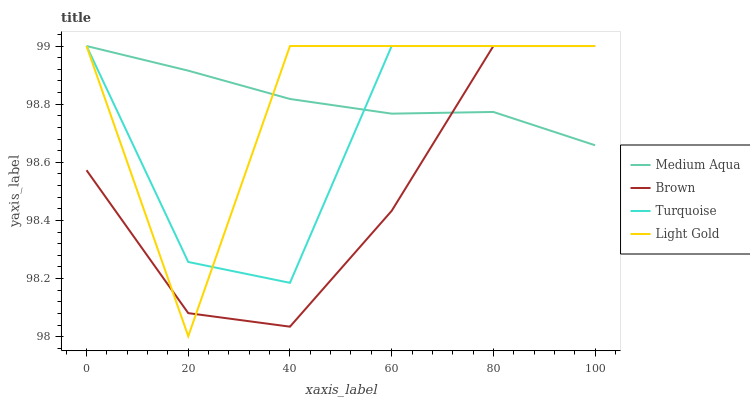Does Brown have the minimum area under the curve?
Answer yes or no. Yes. Does Medium Aqua have the maximum area under the curve?
Answer yes or no. Yes. Does Turquoise have the minimum area under the curve?
Answer yes or no. No. Does Turquoise have the maximum area under the curve?
Answer yes or no. No. Is Medium Aqua the smoothest?
Answer yes or no. Yes. Is Light Gold the roughest?
Answer yes or no. Yes. Is Turquoise the smoothest?
Answer yes or no. No. Is Turquoise the roughest?
Answer yes or no. No. Does Light Gold have the lowest value?
Answer yes or no. Yes. Does Turquoise have the lowest value?
Answer yes or no. No. Does Medium Aqua have the highest value?
Answer yes or no. Yes. Does Light Gold intersect Medium Aqua?
Answer yes or no. Yes. Is Light Gold less than Medium Aqua?
Answer yes or no. No. Is Light Gold greater than Medium Aqua?
Answer yes or no. No. 